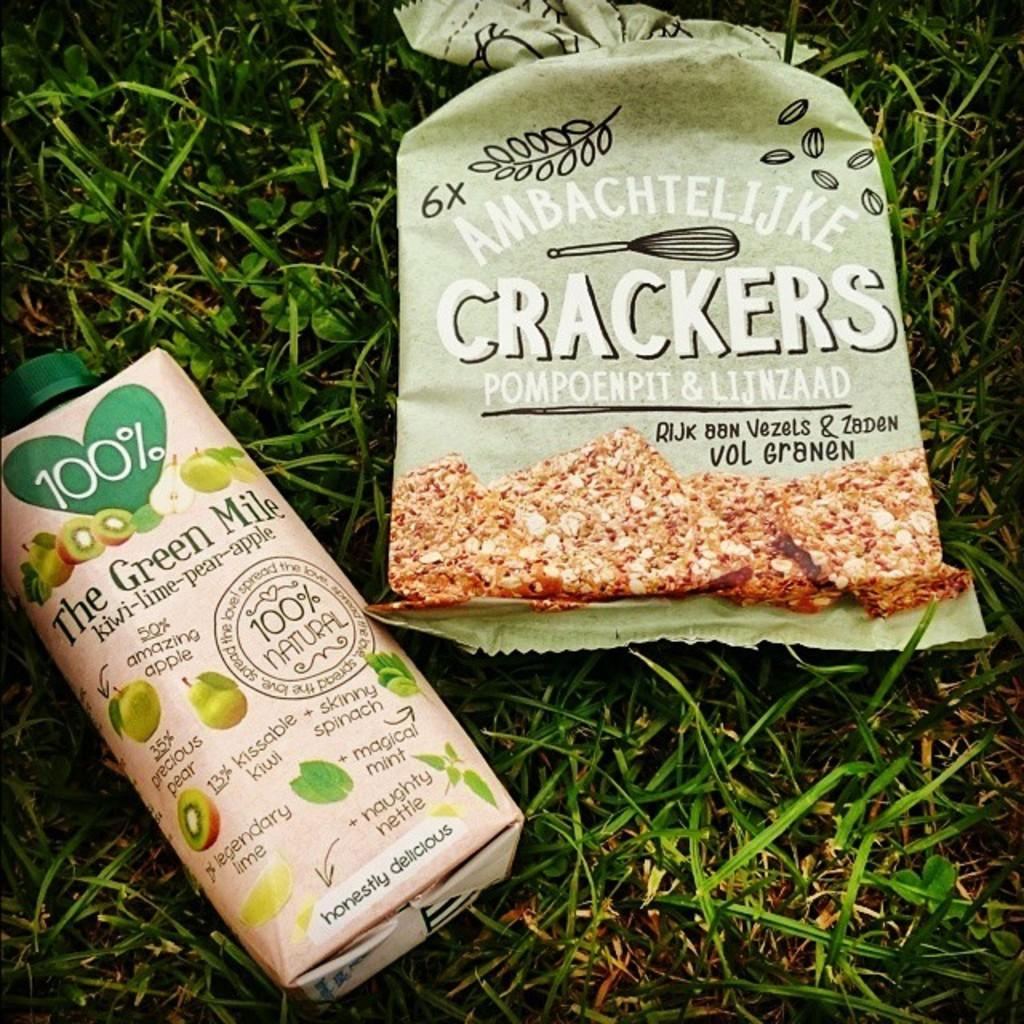<image>
Share a concise interpretation of the image provided. A bag of crackers and a bottle of The Green Mile juice are both laying on grass. 